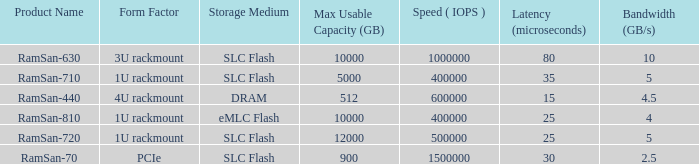List the range distroration for the ramsan-630 3U rackmount. 